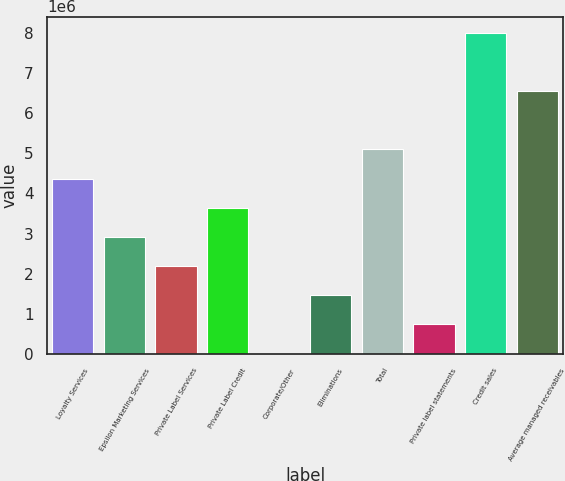<chart> <loc_0><loc_0><loc_500><loc_500><bar_chart><fcel>Loyalty Services<fcel>Epsilon Marketing Services<fcel>Private Label Services<fcel>Private Label Credit<fcel>Corporate/Other<fcel>Eliminations<fcel>Total<fcel>Private label statements<fcel>Credit sales<fcel>Average managed receivables<nl><fcel>4.37067e+06<fcel>2.91956e+06<fcel>2.194e+06<fcel>3.64512e+06<fcel>17337<fcel>1.46845e+06<fcel>5.09623e+06<fcel>742893<fcel>7.99845e+06<fcel>6.54734e+06<nl></chart> 